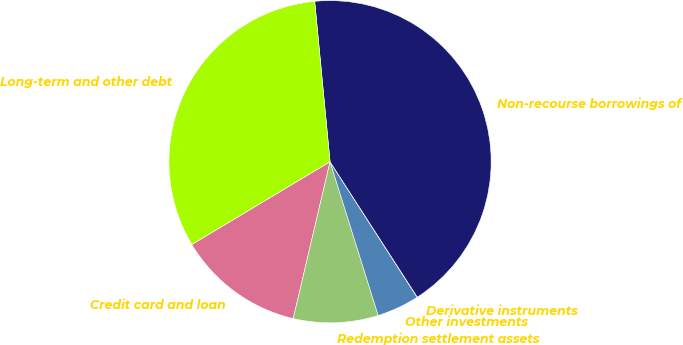<chart> <loc_0><loc_0><loc_500><loc_500><pie_chart><fcel>Credit card and loan<fcel>Redemption settlement assets<fcel>Other investments<fcel>Derivative instruments<fcel>Non-recourse borrowings of<fcel>Long-term and other debt<nl><fcel>12.74%<fcel>8.5%<fcel>4.26%<fcel>0.02%<fcel>42.41%<fcel>32.07%<nl></chart> 